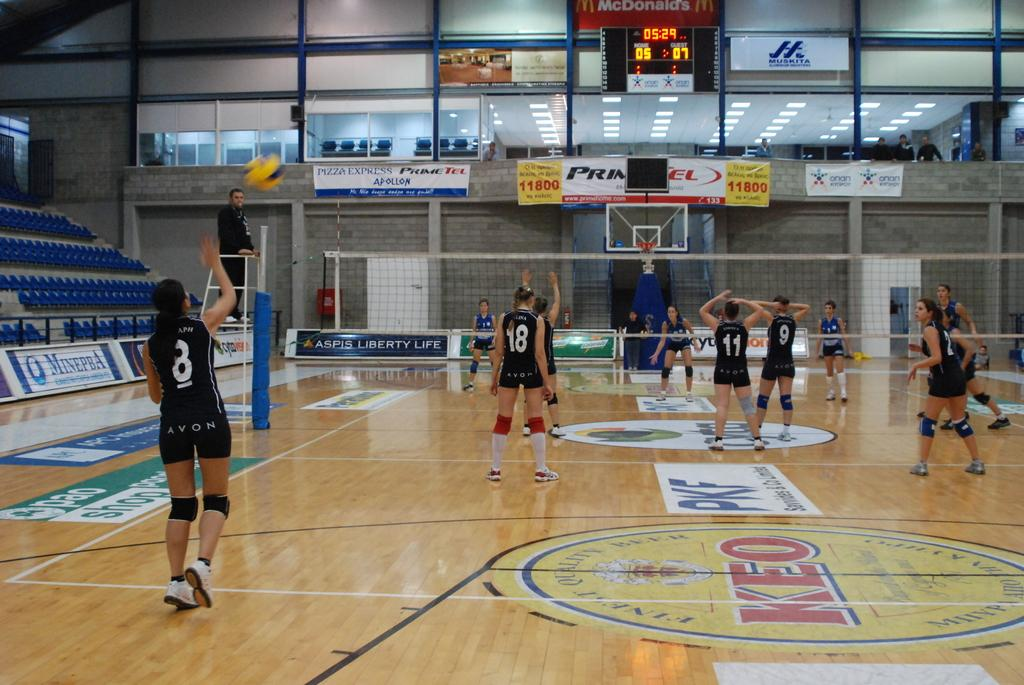<image>
Relay a brief, clear account of the picture shown. A scoreboard in a high school gym that depicts the score as 5 to 7 